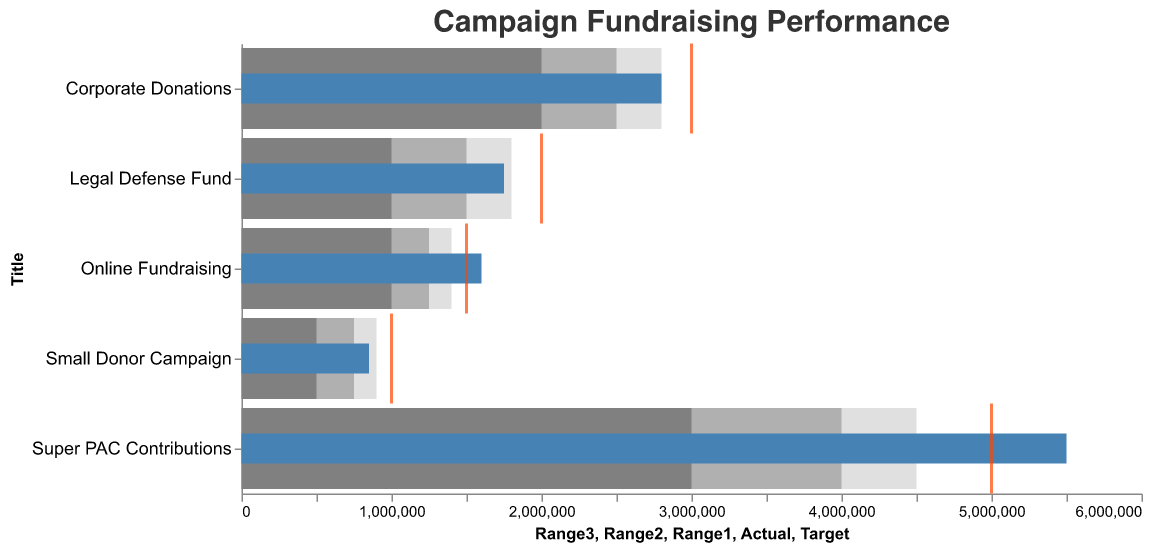What is the title of the chart? The title is written at the top of the chart in a larger font size and reads "Campaign Fundraising Performance".
Answer: Campaign Fundraising Performance Which fund raised more than its target amount? By examining the figure, we can see that the actual funds raised are represented by blue bars and the targets by orange ticks. The “Super PAC Contributions” and “Online Fundraising” categories both exceed their targets.
Answer: Super PAC Contributions and Online Fundraising What is the actual amount raised for the Legal Defense Fund? The blue bar representing the actual amount raised has a corresponding label of "Legal Defense Fund". The length of this bar extends to 1,750,000.
Answer: 1,750,000 Which category has the lowest fundraising target? The orange ticks represent targets; the position of the ticks along the x-axis shows the value. The “Small Donor Campaign” has the lowest tick position at 1,000,000.
Answer: Small Donor Campaign Comparing “Corporate Donations” and “Legal Defense Fund,” which has a higher actual fundraising amount? The blue bars representing the actual amounts raised show that "Corporate Donations" has a value of 2,800,000, while "Legal Defense Fund" has 1,750,000.
Answer: Corporate Donations How much more did “Super PAC Contributions” raise compared to their target? The target for “Super PAC Contributions” is 5,000,000 (orange tick), and the actual amount raised is 5,500,000 (blue bar). The difference is 5,500,000 - 5,000,000.
Answer: 500,000 What is the range of the goals for the “Online Fundraising” campaign? The range values are shown as segmented background bars. For “Online Fundraising,” the lowest range is 1,000,000, the middle range threshold is 1,250,000, and the highest range threshold is 1,400,000.
Answer: 1,000,000 to 1,400,000 Which campaign is closest to meeting its target but hasn't fully met it? The blue bar (actual) and orange tick (target) for “Corporate Donations” are very close. The actual is 2,800,000, and the target is 3,000,000.
Answer: Corporate Donations What is the difference between the targets of the "Legal Defense Fund" and "Corporate Donations"? The target for “Legal Defense Fund” is 2,000,000, and for “Corporate Donations” is 3,000,000. The difference is 3,000,000 - 2,000,000.
Answer: 1,000,000 